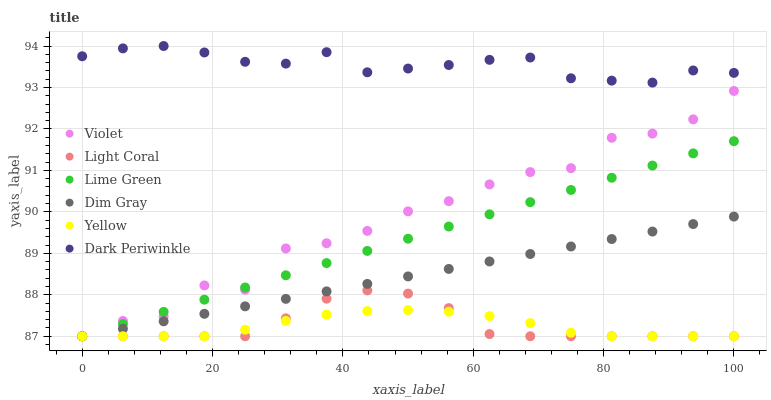Does Yellow have the minimum area under the curve?
Answer yes or no. Yes. Does Dark Periwinkle have the maximum area under the curve?
Answer yes or no. Yes. Does Light Coral have the minimum area under the curve?
Answer yes or no. No. Does Light Coral have the maximum area under the curve?
Answer yes or no. No. Is Lime Green the smoothest?
Answer yes or no. Yes. Is Violet the roughest?
Answer yes or no. Yes. Is Yellow the smoothest?
Answer yes or no. No. Is Yellow the roughest?
Answer yes or no. No. Does Dim Gray have the lowest value?
Answer yes or no. Yes. Does Dark Periwinkle have the lowest value?
Answer yes or no. No. Does Dark Periwinkle have the highest value?
Answer yes or no. Yes. Does Light Coral have the highest value?
Answer yes or no. No. Is Dim Gray less than Dark Periwinkle?
Answer yes or no. Yes. Is Dark Periwinkle greater than Lime Green?
Answer yes or no. Yes. Does Yellow intersect Light Coral?
Answer yes or no. Yes. Is Yellow less than Light Coral?
Answer yes or no. No. Is Yellow greater than Light Coral?
Answer yes or no. No. Does Dim Gray intersect Dark Periwinkle?
Answer yes or no. No. 